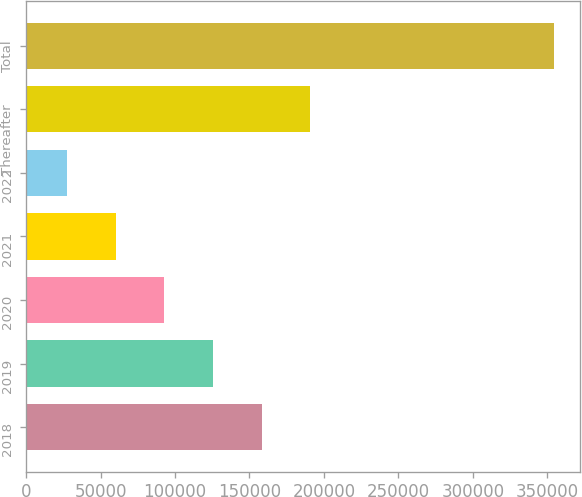Convert chart. <chart><loc_0><loc_0><loc_500><loc_500><bar_chart><fcel>2018<fcel>2019<fcel>2020<fcel>2021<fcel>2022<fcel>Thereafter<fcel>Total<nl><fcel>158194<fcel>125505<fcel>92816.2<fcel>60127.1<fcel>27438<fcel>190884<fcel>354329<nl></chart> 